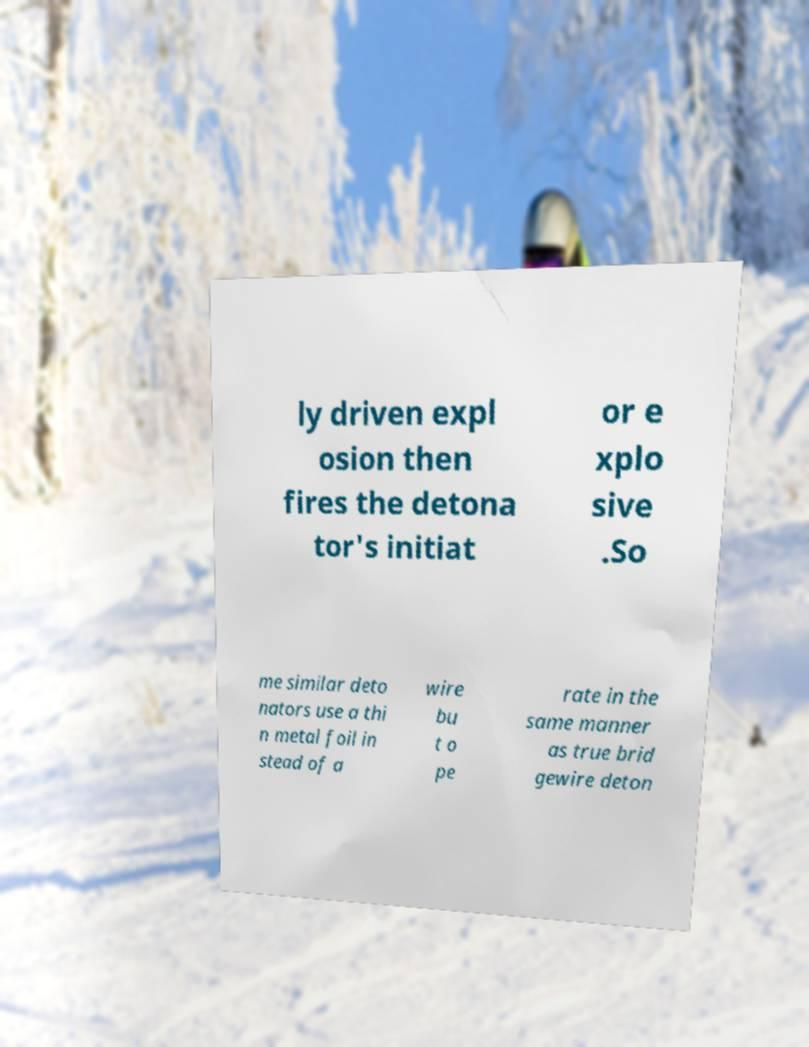What messages or text are displayed in this image? I need them in a readable, typed format. ly driven expl osion then fires the detona tor's initiat or e xplo sive .So me similar deto nators use a thi n metal foil in stead of a wire bu t o pe rate in the same manner as true brid gewire deton 